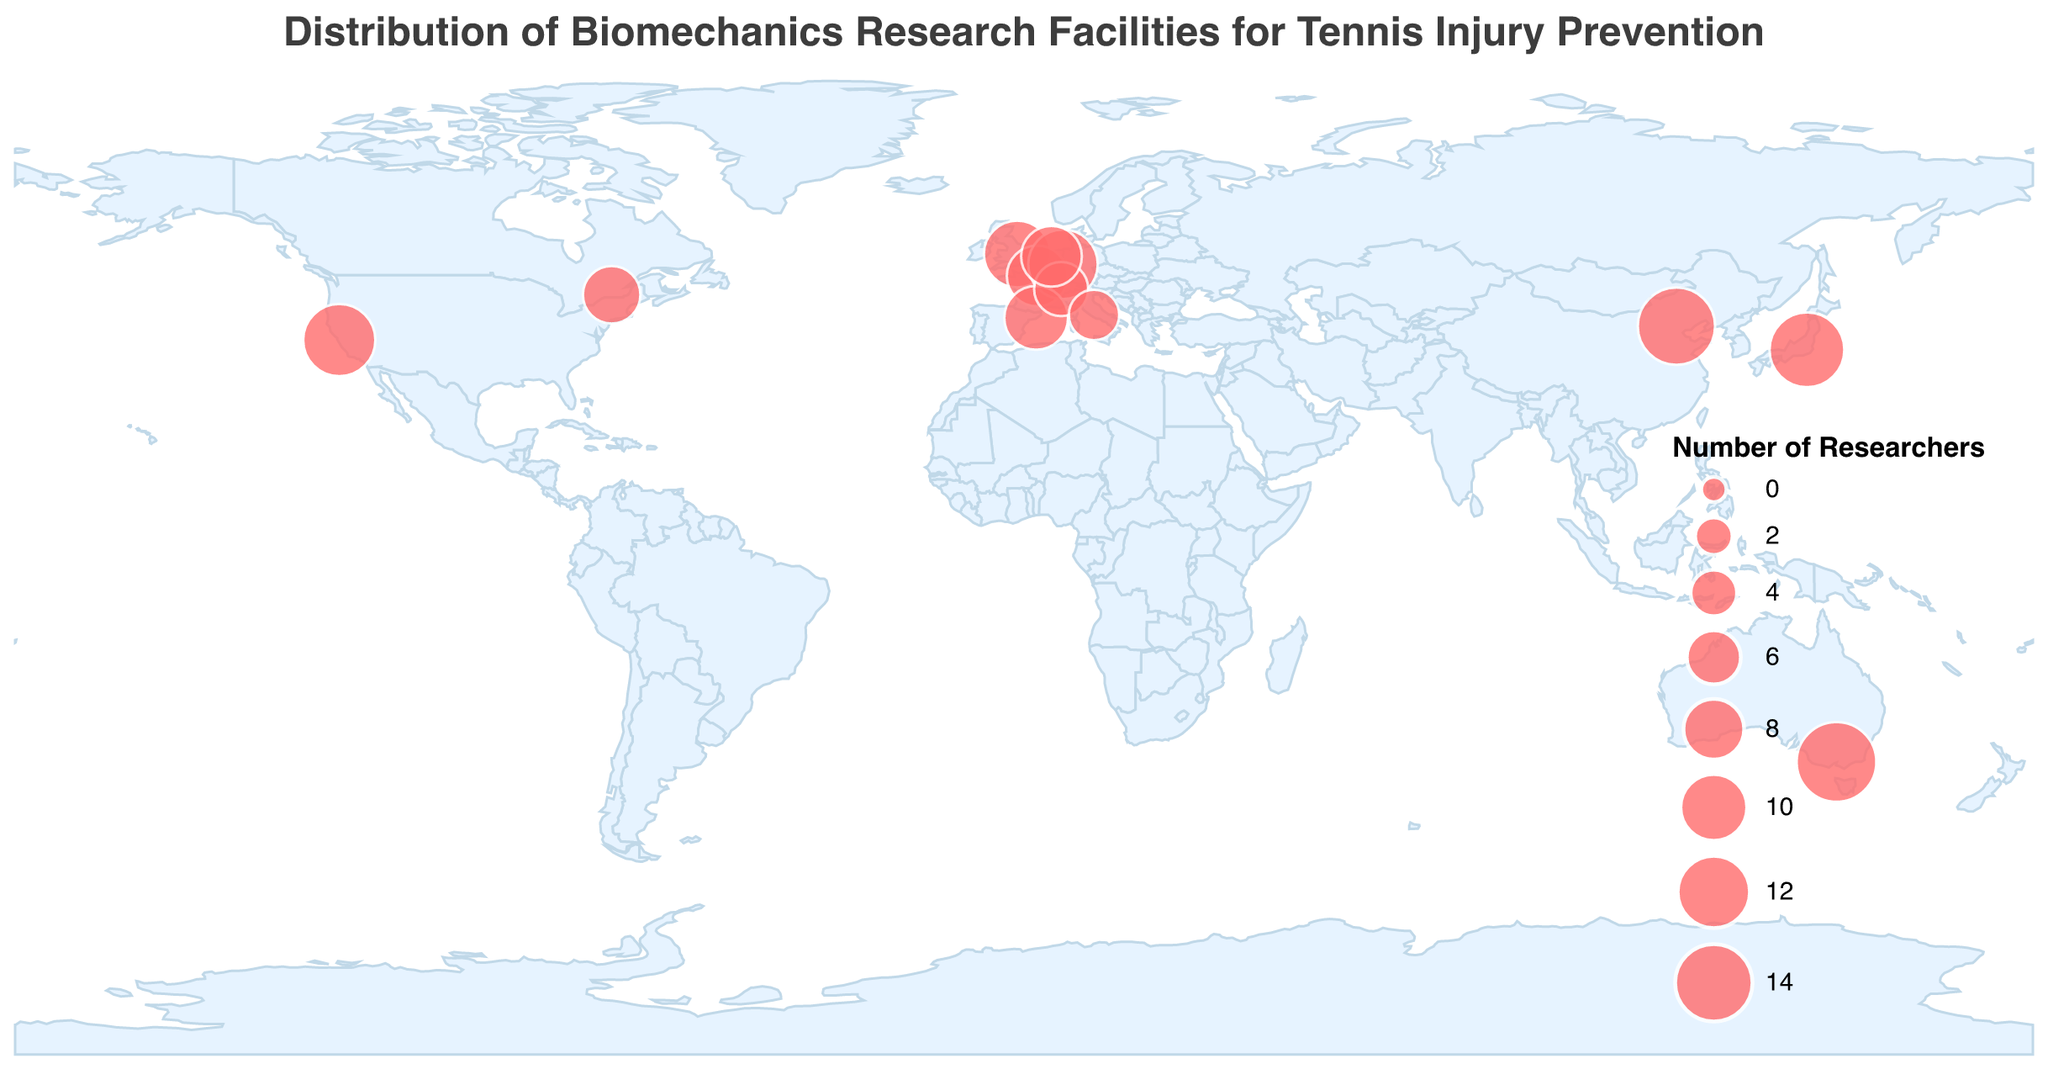Which country has the facility with the highest number of researchers? By examining the size of the circles on the map, which represents the number of researchers, the largest circle is in Melbourne, Australia. This facility has 15 researchers. Therefore, the country is Australia.
Answer: Australia Which city has the research facility with the fewest number of researchers? The facility in Rome, Italy has the fewest researchers. This can be determined by looking at the smallest circle on the map, which represents only 5 researchers.
Answer: Rome How many research facilities have more than 10 researchers? By counting the number of circles that are significantly larger, we can identify facilities with more than 10 researchers. These are in Stanford (USA), Melbourne (Australia), Tokyo (Japan), and Beijing (China). That is a total of 4 facilities.
Answer: 4 Which facility conducts the highest number of annual tennis injury prevention studies? Referring to the tooltip information for each facility, the "Australian Institute of Sport" in Melbourne conducts the highest number with 10 studies annually.
Answer: Australian Institute of Sport What are the names of the facilities in Europe? Facilities in Europe include: Loughborough University Sports Technology Institute in the UK, French Tennis Federation Research Center in France, German Sport University Biomechanics Department in Germany, High Performance Center (CAR) in Spain, Swiss Federal Institute of Sport Magglingen in Switzerland, Vrije Universiteit Movement Sciences in the Netherlands, and Italian Tennis Federation Research Facility in Italy.
Answer: Loughborough University Sports Technology Institute, French Tennis Federation Research Center, German Sport University Biomechanics Department, High Performance Center (CAR), Swiss Federal Institute of Sport Magglingen, Vrije Universiteit Movement Sciences, Italian Tennis Federation Research Facility Which two facilities have the most similar number of researchers? By checking the sizes of the circles for each facility, "Stanford Biomechanics Lab" (USA) and "German Sport University Biomechanics Department" (Germany) have similar sizes, representing 12 and 11 researchers respectively.
Answer: Stanford Biomechanics Lab and German Sport University Biomechanics Department How many studies does the research facility in Tokyo conduct annually? Using the tooltip information provided for the research facility in Tokyo, Japan, it conducts 9 annual tennis injury prevention studies.
Answer: 9 Which facility in North America has the fewest number of annual studies? Among the North American facilities, the "National Tennis Centre Biomechanics Lab" in Montreal, Canada has the fewest annual studies, which is 4.
Answer: National Tennis Centre Biomechanics Lab What is the sum of researchers in the facilities located in the USA and China? The facility in the USA (Stanford Biomechanics Lab) has 12 researchers, and the facility in China (China Institute of Sport Science) has 14 researchers. Added together, the total number of researchers is 12 + 14 = 26.
Answer: 26 